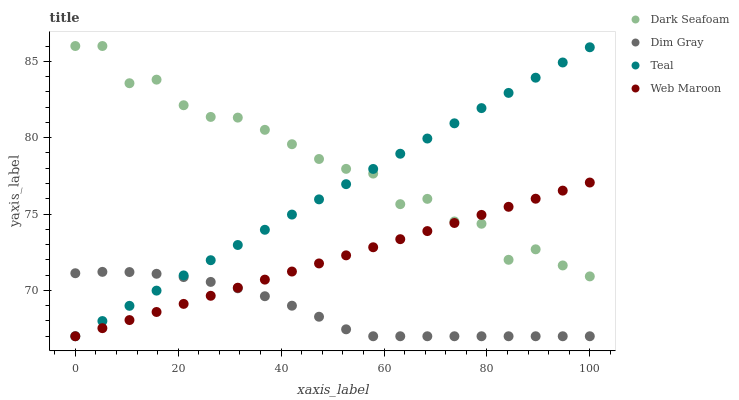Does Dim Gray have the minimum area under the curve?
Answer yes or no. Yes. Does Dark Seafoam have the maximum area under the curve?
Answer yes or no. Yes. Does Web Maroon have the minimum area under the curve?
Answer yes or no. No. Does Web Maroon have the maximum area under the curve?
Answer yes or no. No. Is Web Maroon the smoothest?
Answer yes or no. Yes. Is Dark Seafoam the roughest?
Answer yes or no. Yes. Is Dim Gray the smoothest?
Answer yes or no. No. Is Dim Gray the roughest?
Answer yes or no. No. Does Dim Gray have the lowest value?
Answer yes or no. Yes. Does Dark Seafoam have the highest value?
Answer yes or no. Yes. Does Web Maroon have the highest value?
Answer yes or no. No. Is Dim Gray less than Dark Seafoam?
Answer yes or no. Yes. Is Dark Seafoam greater than Dim Gray?
Answer yes or no. Yes. Does Dim Gray intersect Web Maroon?
Answer yes or no. Yes. Is Dim Gray less than Web Maroon?
Answer yes or no. No. Is Dim Gray greater than Web Maroon?
Answer yes or no. No. Does Dim Gray intersect Dark Seafoam?
Answer yes or no. No. 